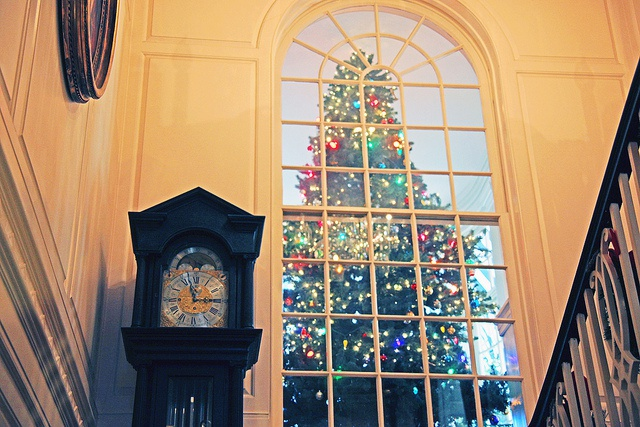Describe the objects in this image and their specific colors. I can see a clock in tan, gray, and darkgray tones in this image. 